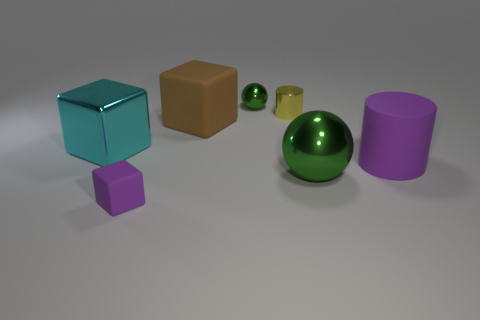There is a big object that is behind the large cylinder and on the right side of the large cyan block; what is its shape? cube 